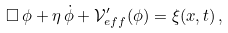Convert formula to latex. <formula><loc_0><loc_0><loc_500><loc_500>\Box \, \phi + \eta \, \dot { \phi } + { \mathcal { V } } ^ { \prime } _ { e f f } ( \phi ) = \xi ( { x } , t ) \, ,</formula> 